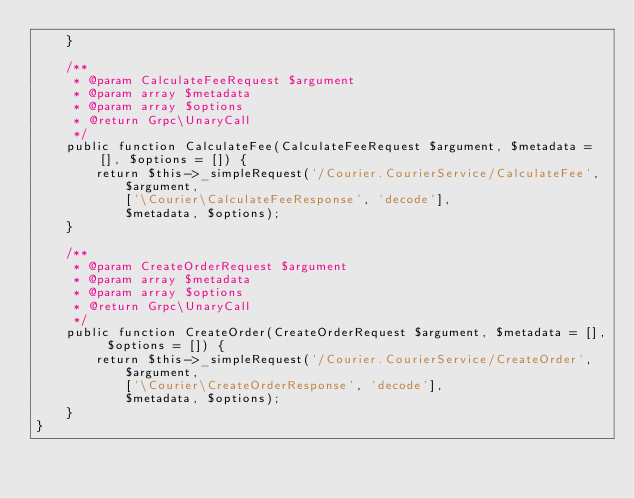<code> <loc_0><loc_0><loc_500><loc_500><_PHP_>    }

    /**
     * @param CalculateFeeRequest $argument
     * @param array $metadata
     * @param array $options
     * @return Grpc\UnaryCall
     */
    public function CalculateFee(CalculateFeeRequest $argument, $metadata = [], $options = []) {
        return $this->_simpleRequest('/Courier.CourierService/CalculateFee',
            $argument,
            ['\Courier\CalculateFeeResponse', 'decode'],
            $metadata, $options);
    }

    /**
     * @param CreateOrderRequest $argument
     * @param array $metadata
     * @param array $options
     * @return Grpc\UnaryCall
     */
    public function CreateOrder(CreateOrderRequest $argument, $metadata = [], $options = []) {
        return $this->_simpleRequest('/Courier.CourierService/CreateOrder',
            $argument,
            ['\Courier\CreateOrderResponse', 'decode'],
            $metadata, $options);
    }
}
</code> 